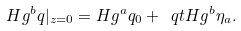<formula> <loc_0><loc_0><loc_500><loc_500>H g ^ { b } q | _ { z = 0 } = H g ^ { a } q _ { 0 } + \ q t H g ^ { b } \eta _ { a } .</formula> 